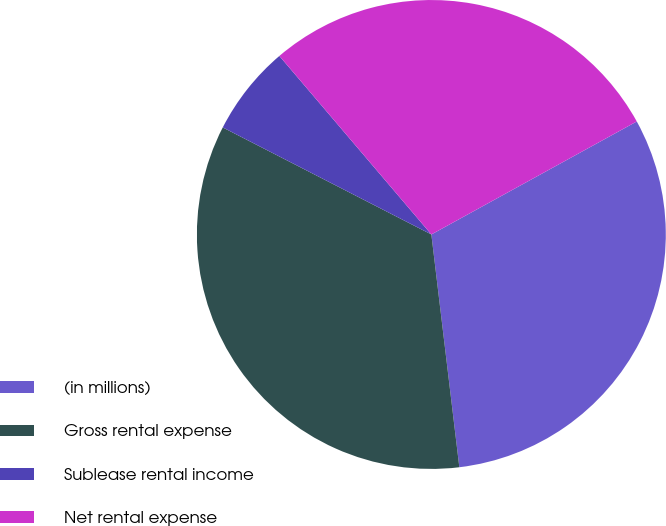Convert chart. <chart><loc_0><loc_0><loc_500><loc_500><pie_chart><fcel>(in millions)<fcel>Gross rental expense<fcel>Sublease rental income<fcel>Net rental expense<nl><fcel>31.1%<fcel>34.45%<fcel>6.23%<fcel>28.22%<nl></chart> 